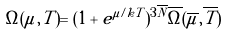<formula> <loc_0><loc_0><loc_500><loc_500>\Omega ( \mu , T ) = ( 1 + e ^ { \mu / k T } ) ^ { 3 { \overline { N } } } { \overline { \Omega } } ( { \overline { \mu } } , { \overline { T } } )</formula> 